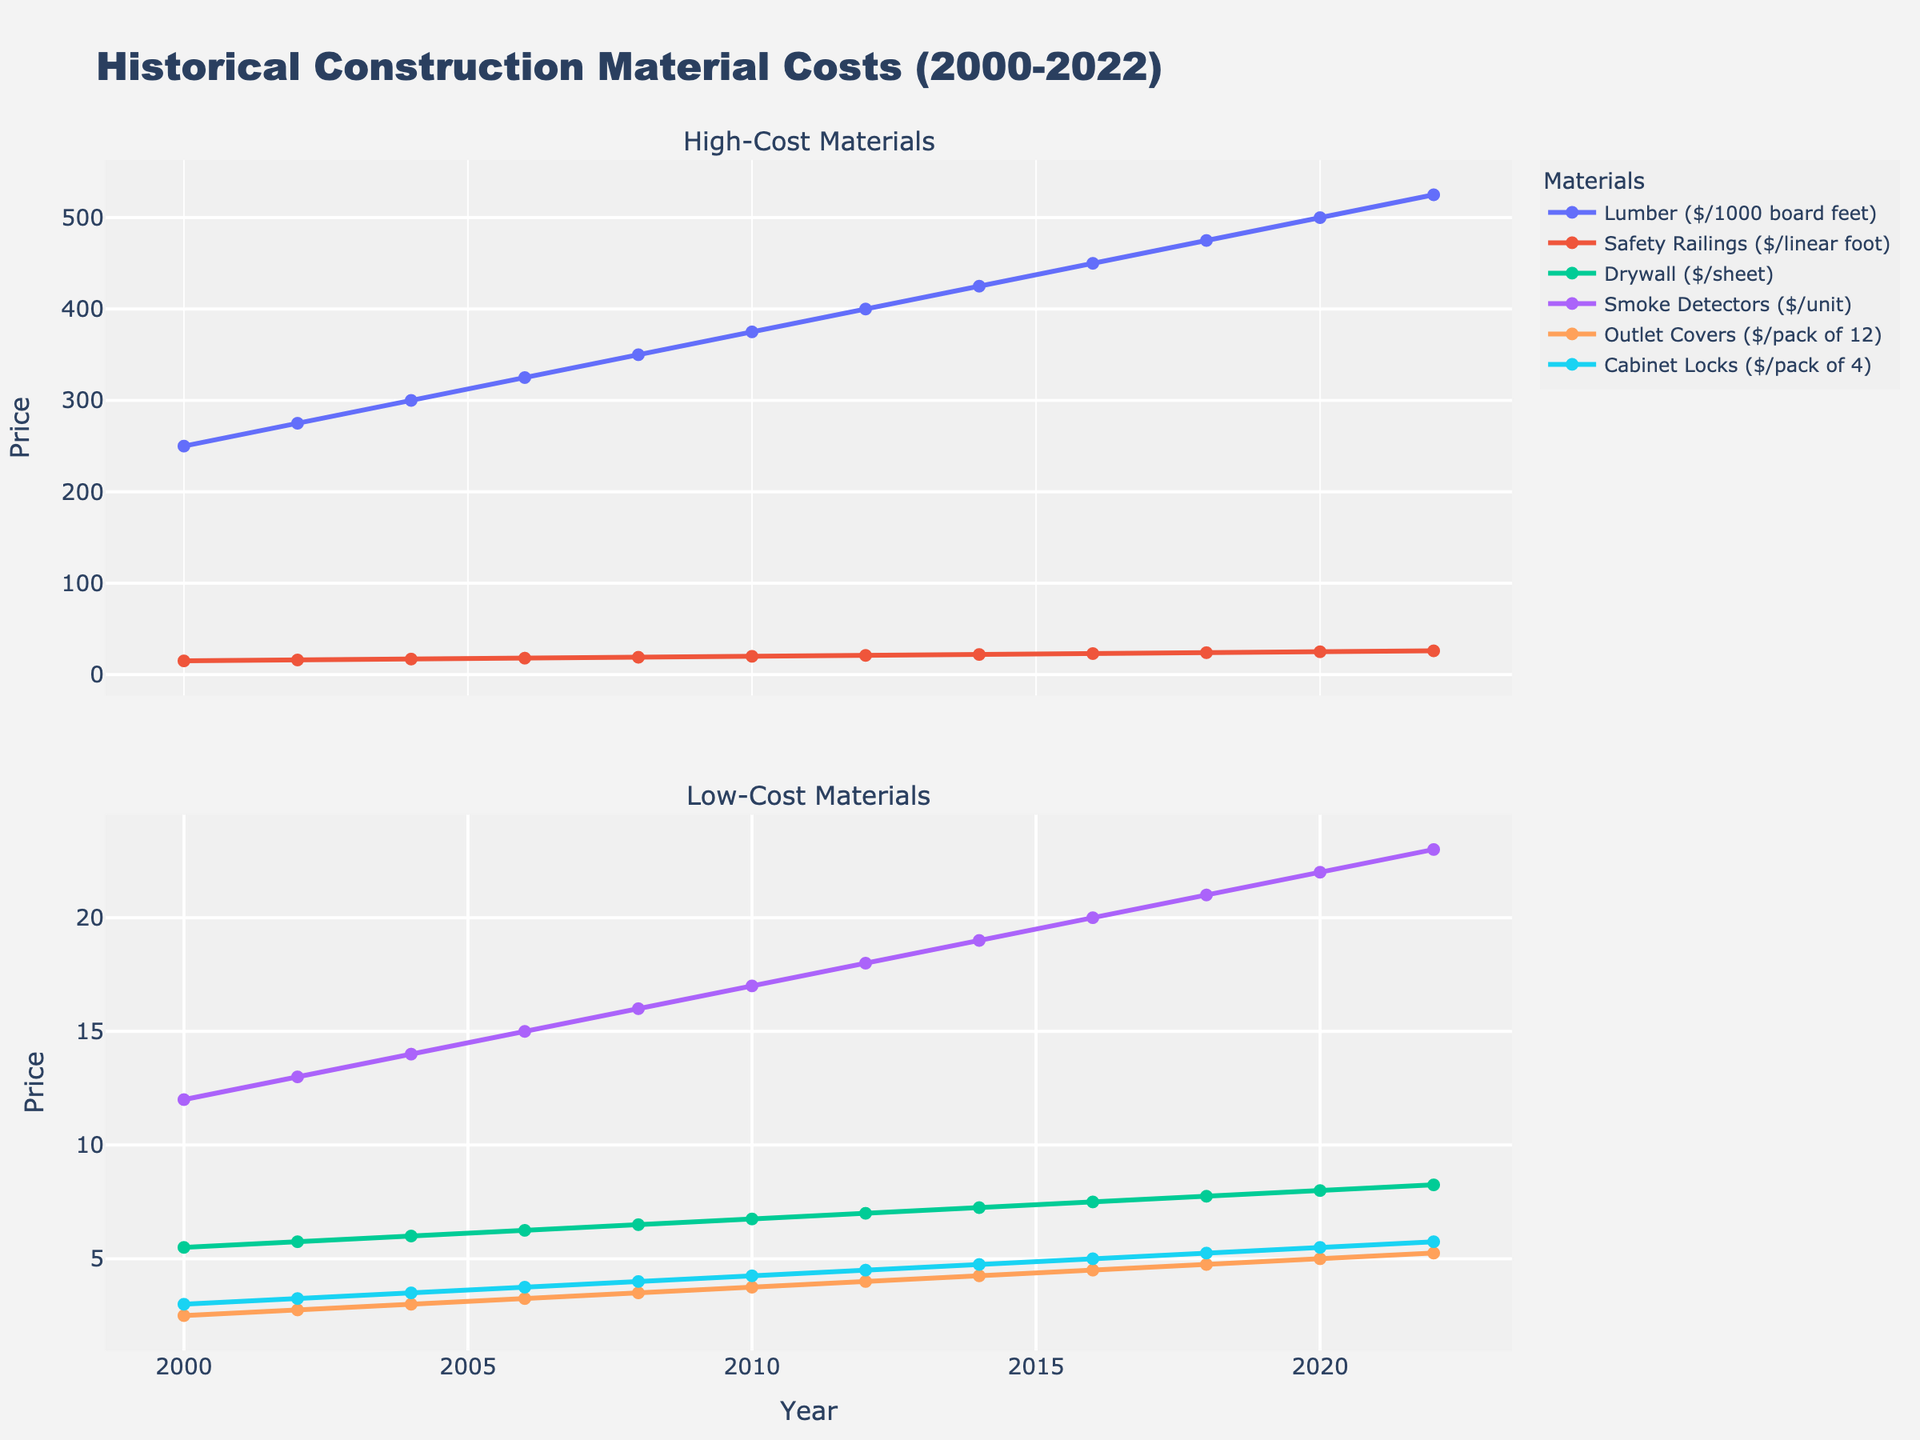Which material had the highest price in 2022? By observing the "High-Cost Materials" subplot, we can see that Lumber had the highest price in 2022 among all materials shown.
Answer: Lumber What is the percent increase in the price of Smoke Detectors from 2000 to 2022? In 2000, the price of Smoke Detectors was $12, and in 2022, it was $23. The percent increase can be calculated as [(23 - 12) / 12] * 100 = 91.67%.
Answer: 91.67% Which material showed the steepest increase in price from 2000 to 2022 in the 'Low-Cost Materials' plot? By visually comparing the slopes of the lines in the 'Low-Cost Materials' subplot, Smoke Detectors showed the steepest increase.
Answer: Smoke Detectors Between 2002 and 2010, which material had the smallest price change? By looking at the slopes of the lines between 2002 and 2010 in both subplots, Cabinet Locks had the smallest price change.
Answer: Cabinet Locks How much more expensive was Lumber compared to Safety Railings in 2012? The price of Lumber in 2012 was $400 and the price of Safety Railings was $21. The difference is $400 - $21 = $379.
Answer: $379 On average, how much did the price of Outlet Covers increase each year from 2000 to 2022? The price of Outlet Covers increased from $2.50 in 2000 to $5.25 in 2022. The average annual increase can be calculated as (5.25 - 2.50) / (2022 - 2000) = 0.125 dollars per year.
Answer: 0.125 dollars per year Which year did Drywall reach the $8.00 mark per sheet? Observing the 'Low-Cost Materials' subplot, Drywall reached exactly $8.00 per sheet in the year 2020.
Answer: 2020 Compare the prices of Outlet Covers and Cabinet Locks in 2006. Which one was cheaper and by how much? In 2006, Outlet Covers were priced at $3.25 per pack, and Cabinet Locks were $3.75 per pack. Outlet Covers were cheaper by $3.75 - $3.25 = $0.50.
Answer: Outlet Covers, $0.50 What is the total cost of buying one unit of each material in 2022? The prices in 2022 are: Lumber: $525, Drywall: $8.25, Safety Railings: $26, Smoke Detectors: $23, Outlet Covers: $5.25, Cabinet Locks: $5.75. The total cost is 525 + 8.25 + 26 + 23 + 5.25 + 5.75 = $593.25.
Answer: $593.25 During which period did Safety Railings see the most significant price increase? By examining the 'High-Cost Materials' subplot, the most significant price increase for Safety Railings occurred between 2000 and 2006.
Answer: 2000-2006 